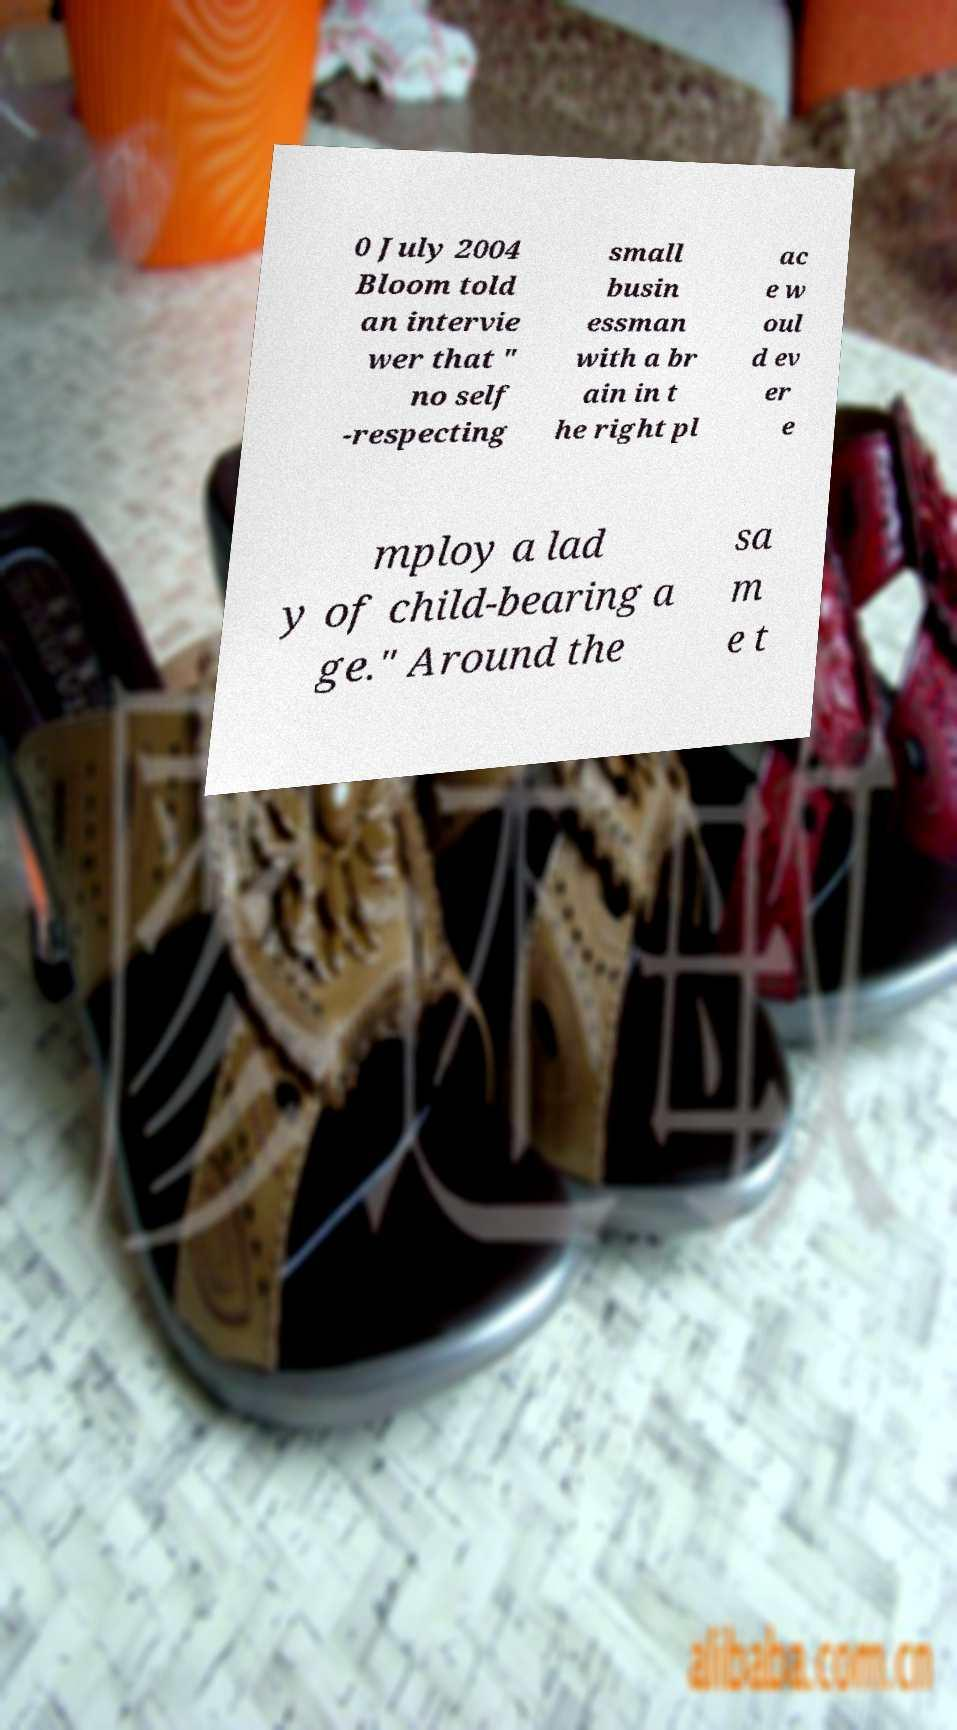Can you read and provide the text displayed in the image?This photo seems to have some interesting text. Can you extract and type it out for me? 0 July 2004 Bloom told an intervie wer that " no self -respecting small busin essman with a br ain in t he right pl ac e w oul d ev er e mploy a lad y of child-bearing a ge." Around the sa m e t 